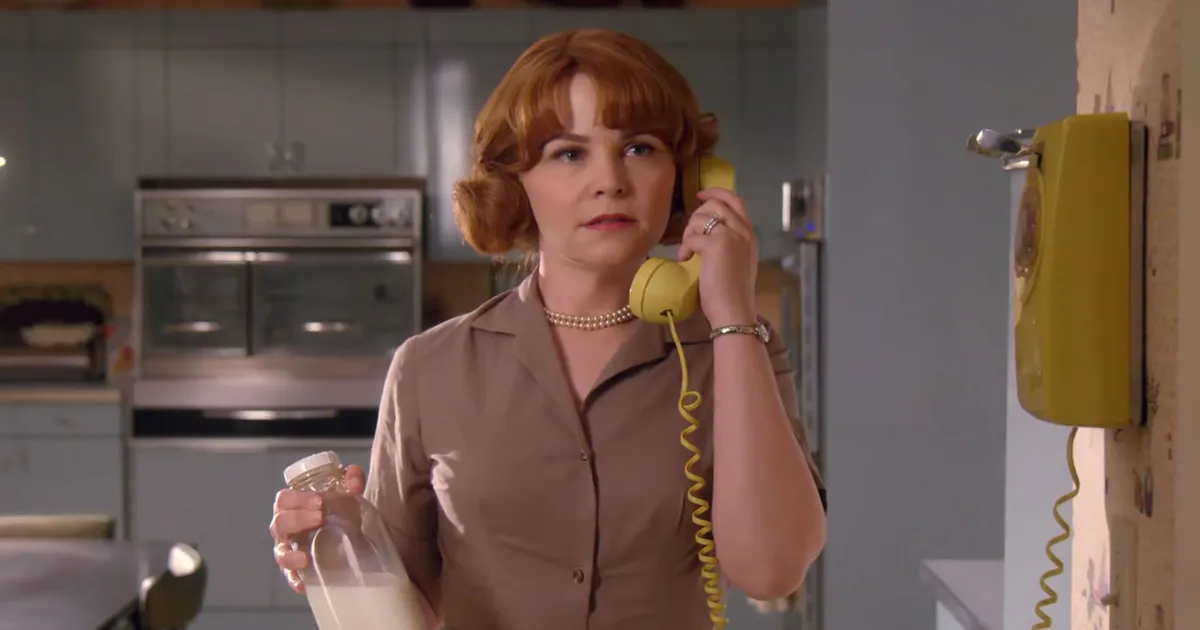What does this setting tell you about the time period or context in which it was taken? The setting of the image, with its retro kitchen design, yellow rotary phone, and glass milk bottle, evokes a sense of nostalgia for the mid-20th century, possibly the 1950s or 1960s. The styling of the character, with a neat bob hairstyle, beige dress, and pearl necklace, further supports this time frame. The overall ambiance suggests a time when such kitchens, with their pastel color schemes and vintage appliances, were common, offering a glimpse into domestic life from that era. 